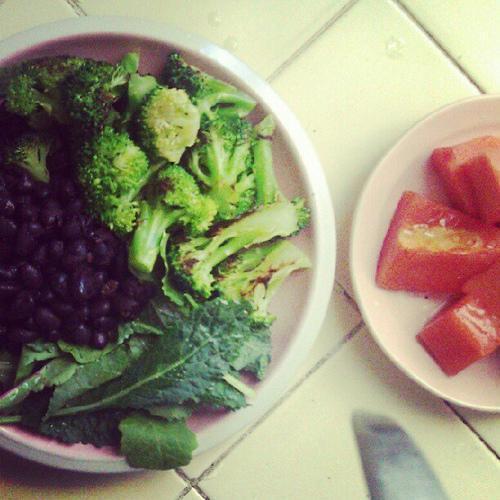How many plates are there?
Give a very brief answer. 2. 